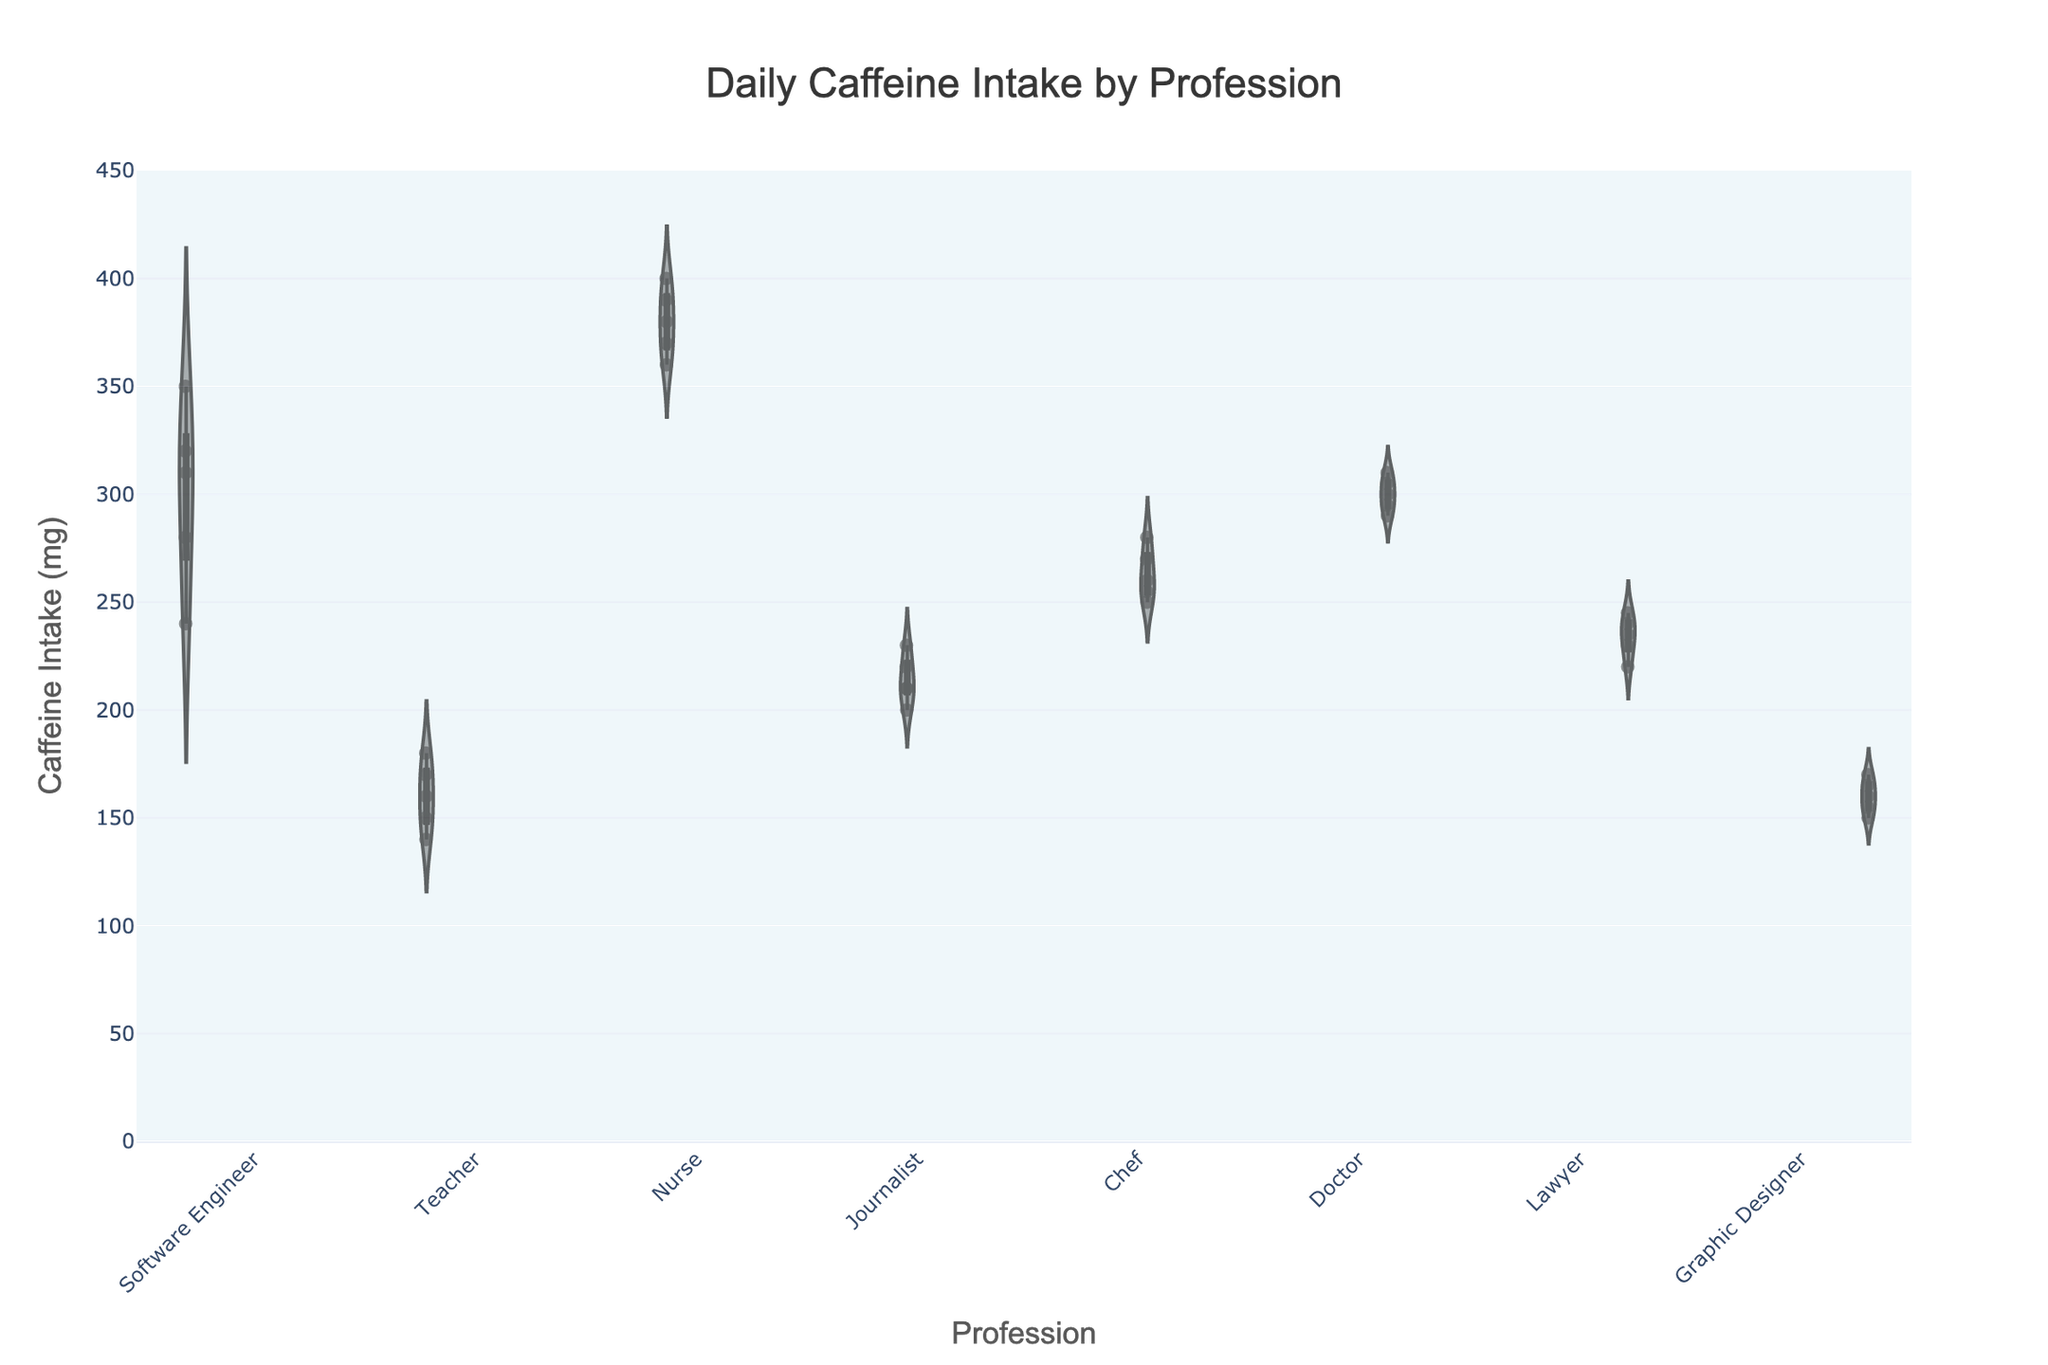What is the title of the figure? The title is located at the top center of the figure.
Answer: Daily Caffeine Intake by Profession What is the range of the y-axis? The y-axis on the figure shows a range from 0 to 450 mg.
Answer: 0-450 mg Which profession has the widest spread of caffeine intake? By inspecting the width of the violin plots, the profession with the widest spread of caffeine intake data points can be identified. Nurses have the widest spread among all the professions.
Answer: Nurses How many professions are represented in the figure? Count the number of distinct violin plots, each representing a different profession. There are 8 violin plots.
Answer: 8 Which profession has the highest mean caffeine intake? Look at the meanline (horizontal line) within the violin plot for each profession. Nurses have the highest mean caffeine intake.
Answer: Nurses What's the median caffeine intake for Teachers? The median of a dataset is the middle value when the values are sorted in ascending order. For Teachers, the sorted data are [140, 150, 160, 170, 180]. The median is the middle value: 160 mg.
Answer: 160 mg What's the median caffeine intake of Software Engineers? For Software Engineers, the sorted data are [240, 280, 310, 320, 350]. The median is the middle value: 310 mg.
Answer: 310 mg What is the average caffeine intake for Journalists? Summing the caffeine intake values for Journalists (200+210+210+220+230=1070), then dividing by the number of data points (5), the average intake is 1070/5 = 214 mg.
Answer: 214 mg Which profession has the lowest range of caffeine intake? To find the lowest range, look for the profession with the narrowest spread within their violin plot—a smaller difference between minimum and maximum values. Graphic Designers have the smallest range, from 150 to 170 mg.
Answer: Graphic Designers Is the mean caffeine intake higher for Doctors or Lawyers? Compare the meanlines of the Doctors and Lawyers violin plots. Doctors have a higher mean intake.
Answer: Doctors Which profession has a higher median caffeine intake, Chefs or Doctors? Compare the horizontal lines in the middle of the violin plot for each profession. Doctors have a higher median intake.
Answer: Doctors In which profession is the spread of individual caffeine intake points visibly most uniform? Inspect the density and distribution of points within each violin plot. Software Engineers have a more uniform spread compared to others.
Answer: Software Engineers Which profession shows the highest variability in caffeine intake? The profession with the largest and visually varying spread within the violin plot shows highest variability. Nurses have the highest variability in caffeine intake.
Answer: Nurses 